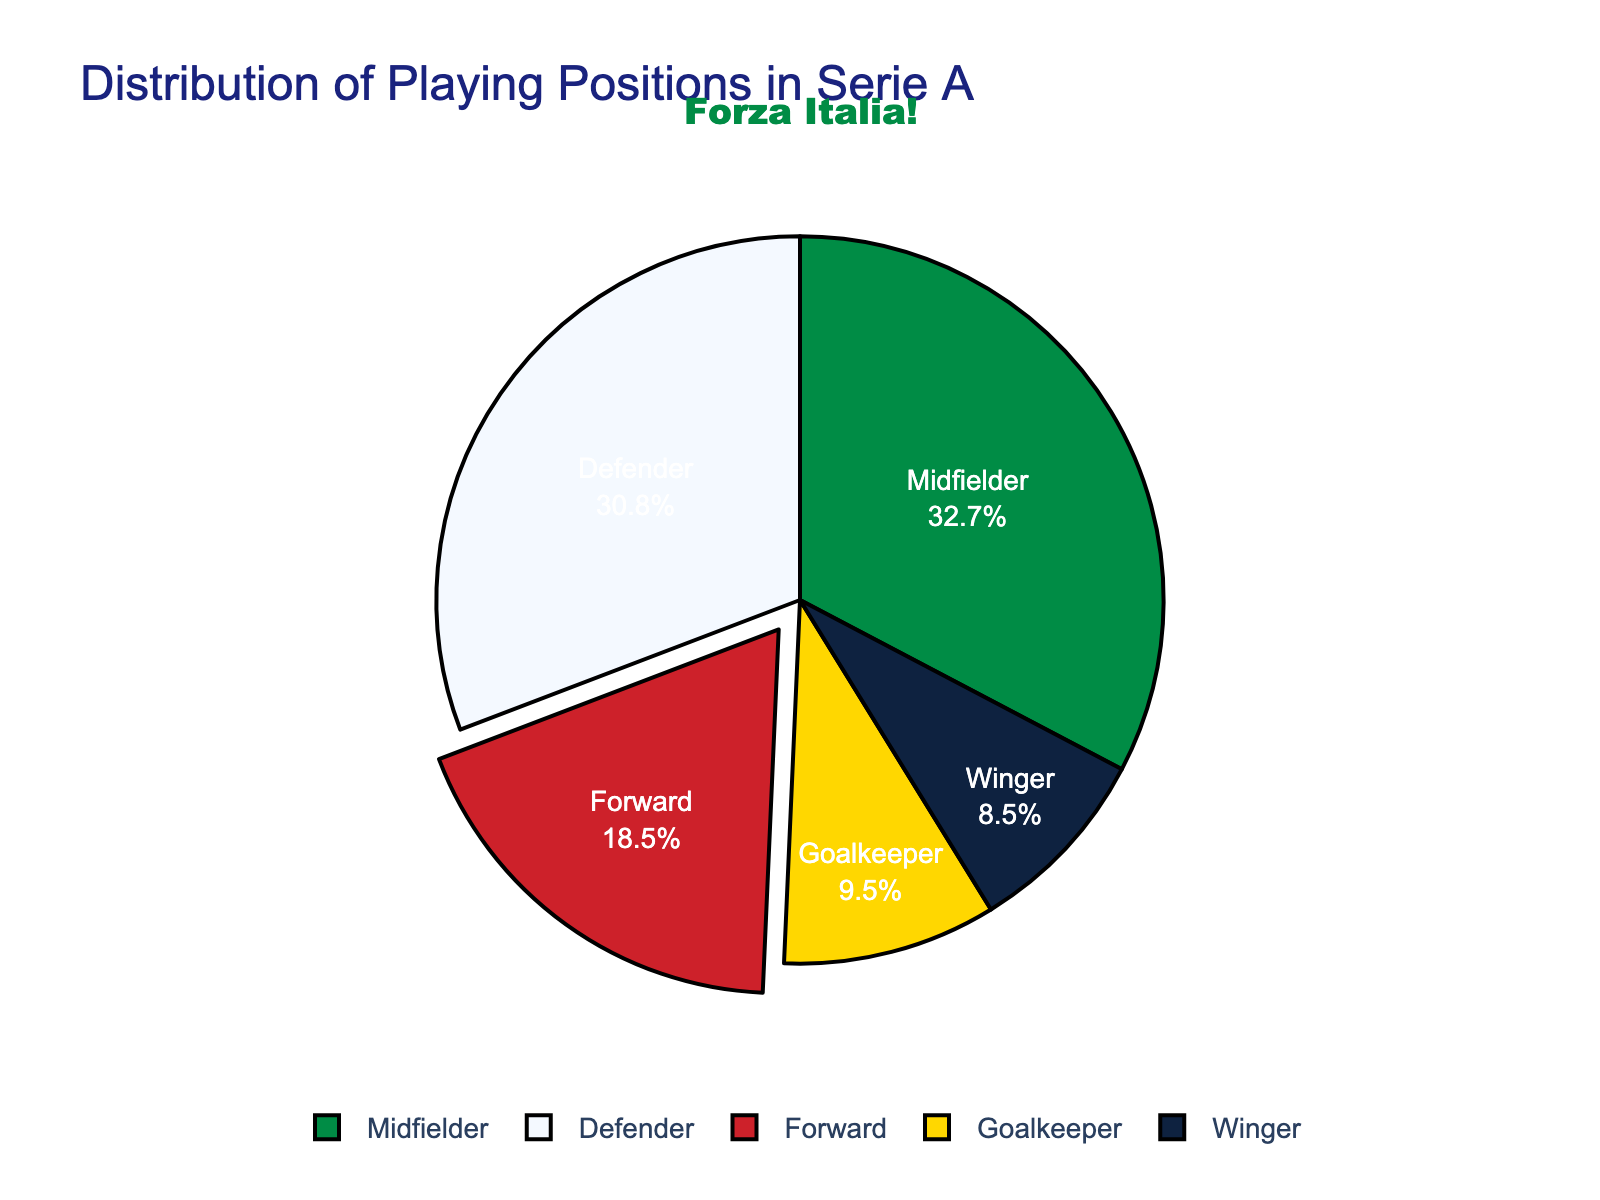What's the position with the highest percentage in Serie A? Look at the chart where the segments represent different positions. Identify the one with the largest segment. The Midfielder segment is the largest.
Answer: Midfielder Which position has the smallest representation in the distribution? Review the chart and identify the smallest segment. The Winger segment is the smallest.
Answer: Winger By how much does the percentage of Midfielders exceed that of Forwards and Wingers combined? Identify the percentages of Midfielders, Forwards, and Wingers. Midfielders: 32.7%, Forwards: 18.5%, and Wingers: 8.5%. Calculate the sum of Forwards and Wingers: 18.5 + 8.5 = 27%. Subtract this from the Midfielders' percentage: 32.7 - 27 = 5.7%.
Answer: 5.7% Are there more Defenders or Goalkeepers? Look at the segments for Defenders and Goalkeepers. The Defenders have a larger segment.
Answer: Defenders What is the combined percentage of Defensive positions (Defender and Goalkeeper)? Identify the percentages of Defenders and Goalkeepers. Defenders: 30.8%, Goalkeepers: 9.5%. Add these values together: 30.8 + 9.5 = 40.3%.
Answer: 40.3% Which segment is visually indicated to be the main highlight of the chart? The segment that appears to be "pulled out" or emphasized visually demonstrates the main highlight. The Forward segment is pulled out.
Answer: Forward What is the difference in percentage between Midfielders and Defenders? Identify the percentages of Midfielders and Defenders. Midfielders: 32.7%, Defenders: 30.8%. Find the difference: 32.7 - 30.8 = 1.9%.
Answer: 1.9% In terms of color, how is the goalkeeper position represented? Examine the hue of the segment representing the goalkeeper position. It's represented by a golden-yellow color.
Answer: Golden-yellow How much greater is the combined percentage of Forwards and Goalkeepers compared to Wingers? Identify the percentages of Forwards, Goalkeepers, and Wingers. Forwards: 18.5%, Goalkeepers: 9.5%, Wingers: 8.5%. Calculate the sum of Forwards and Goalkeepers: 18.5 + 9.5 = 28%. Subtract the percentage of Wingers: 28 - 8.5 = 19.5%.
Answer: 19.5% What percentage of all positions is not accounted for by Midfielders? Identify the Midfielders' percentage: 32.7%. Subtract this from 100% to find the not accounted percentage: 100 - 32.7 = 67.3%.
Answer: 67.3% 